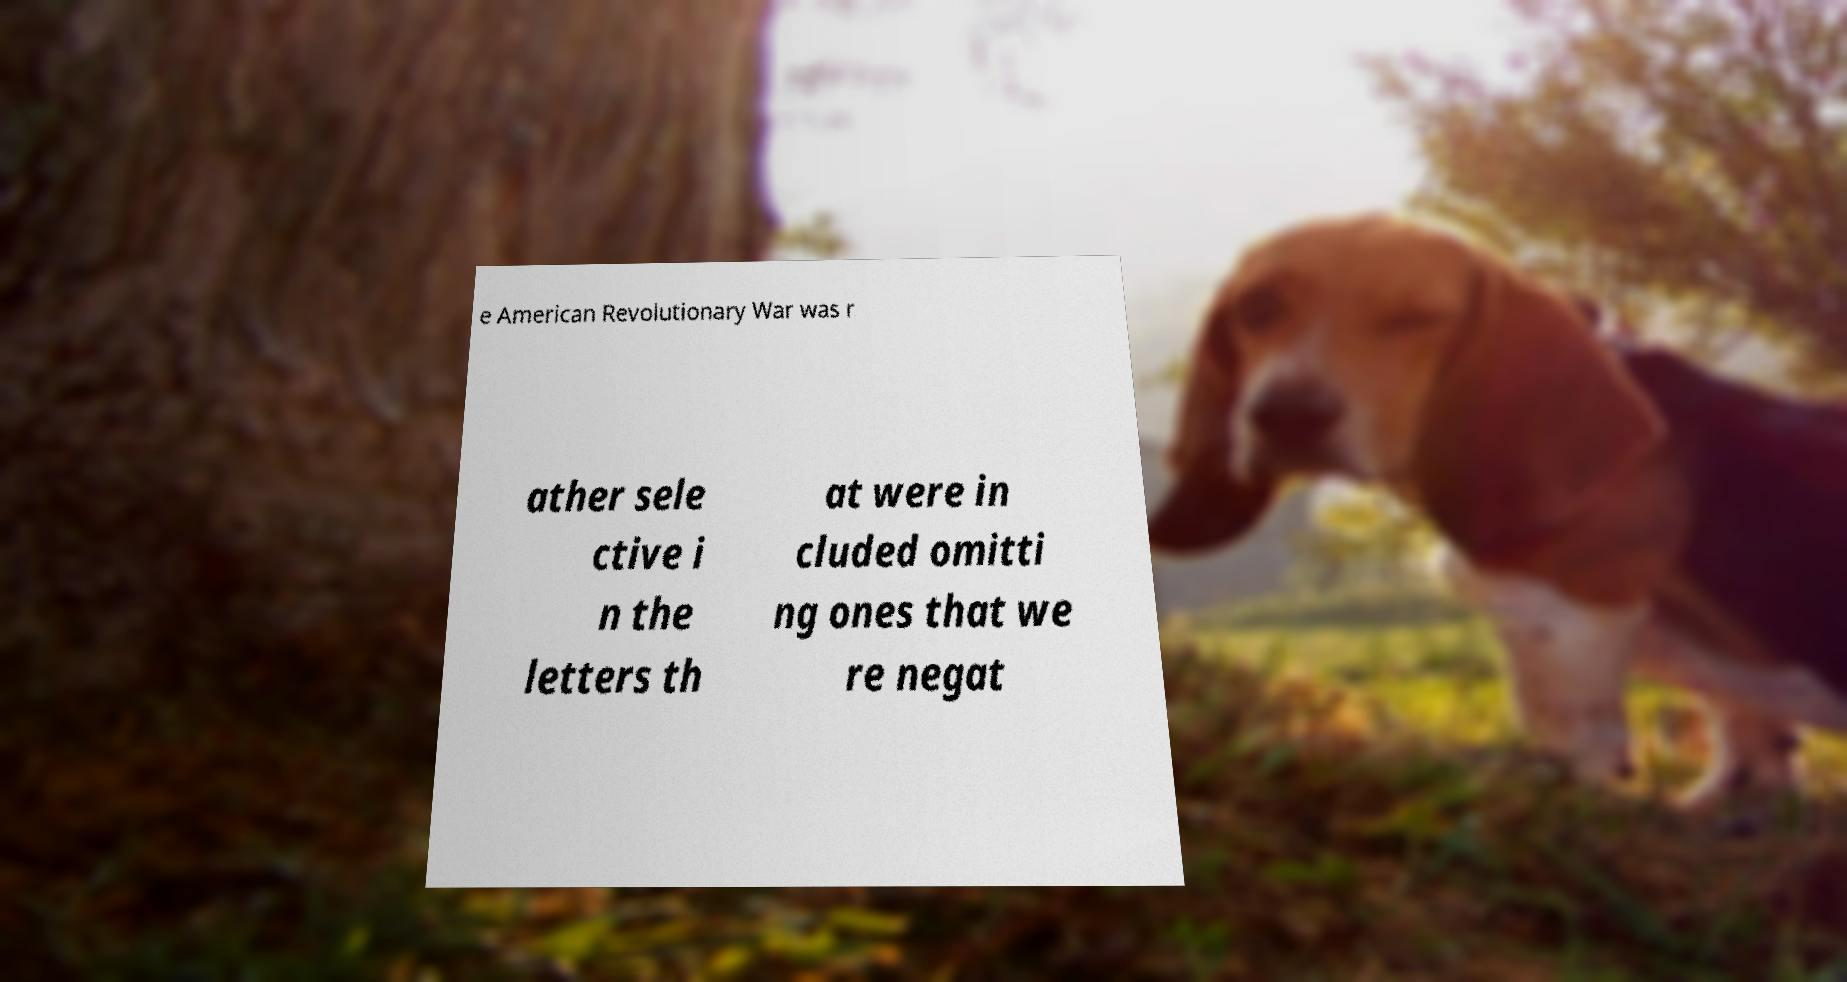Can you accurately transcribe the text from the provided image for me? e American Revolutionary War was r ather sele ctive i n the letters th at were in cluded omitti ng ones that we re negat 